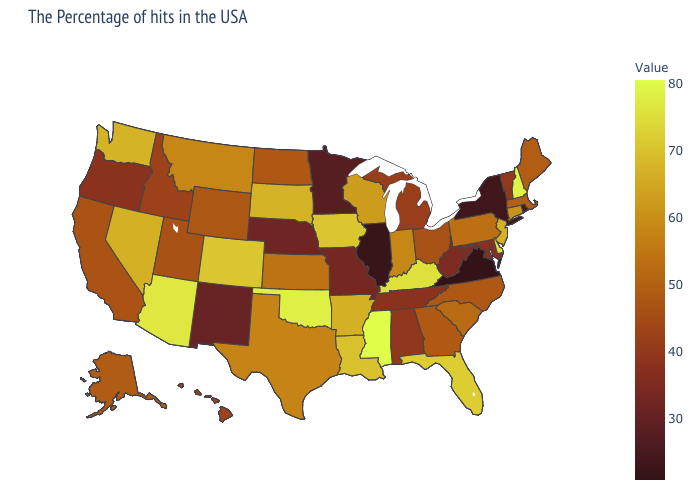Does New Mexico have a higher value than Wyoming?
Concise answer only. No. Among the states that border South Carolina , which have the lowest value?
Answer briefly. North Carolina. Does Massachusetts have the lowest value in the USA?
Be succinct. No. Does Mississippi have the highest value in the USA?
Concise answer only. Yes. 